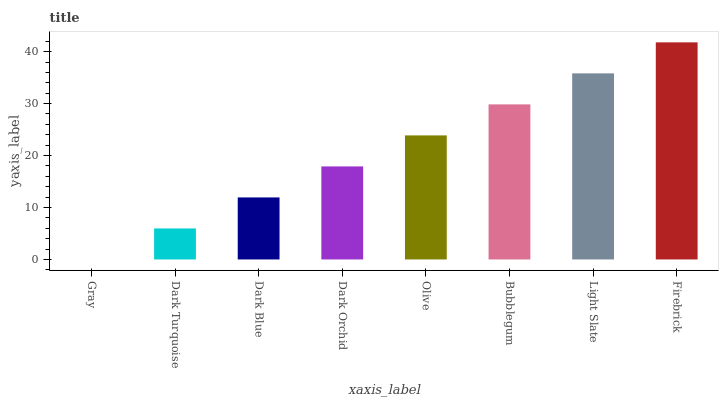Is Gray the minimum?
Answer yes or no. Yes. Is Firebrick the maximum?
Answer yes or no. Yes. Is Dark Turquoise the minimum?
Answer yes or no. No. Is Dark Turquoise the maximum?
Answer yes or no. No. Is Dark Turquoise greater than Gray?
Answer yes or no. Yes. Is Gray less than Dark Turquoise?
Answer yes or no. Yes. Is Gray greater than Dark Turquoise?
Answer yes or no. No. Is Dark Turquoise less than Gray?
Answer yes or no. No. Is Olive the high median?
Answer yes or no. Yes. Is Dark Orchid the low median?
Answer yes or no. Yes. Is Dark Turquoise the high median?
Answer yes or no. No. Is Olive the low median?
Answer yes or no. No. 